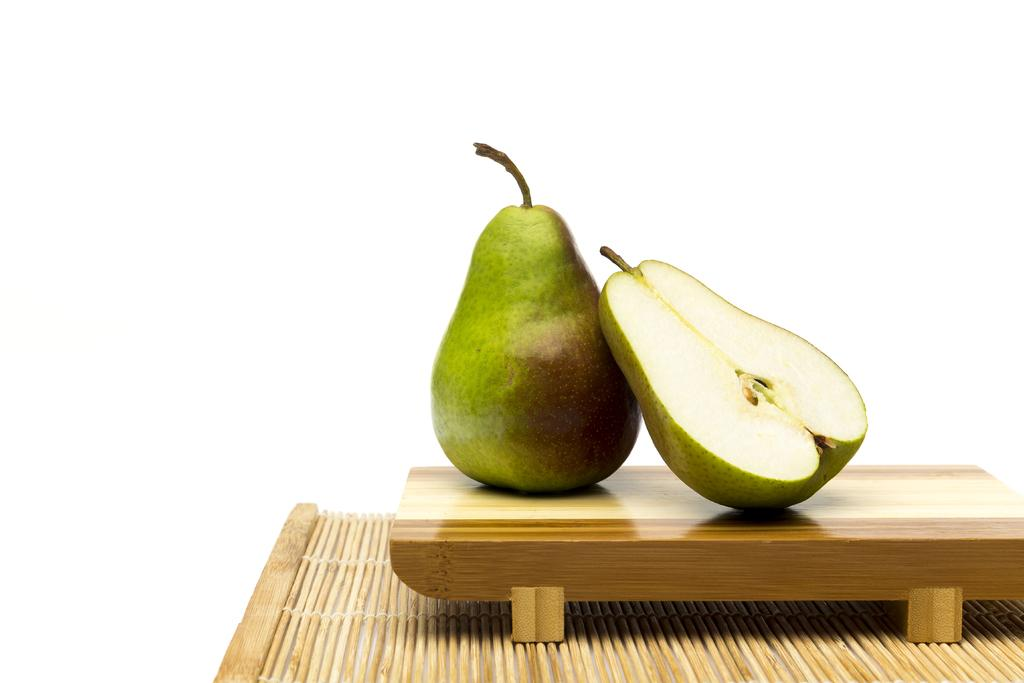What type of fruit is placed on the tray in the image? There are pears placed on a tray in the image. What is located at the bottom of the image? There is a mat at the bottom of the image. What does the front of the wish look like in the image? There is no wish present in the image, so it is not possible to describe the front of it. 